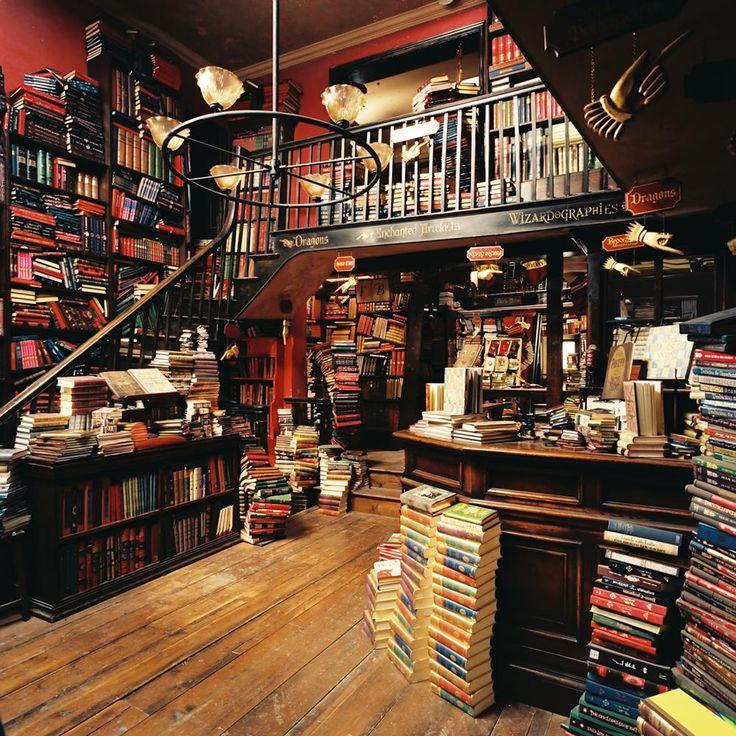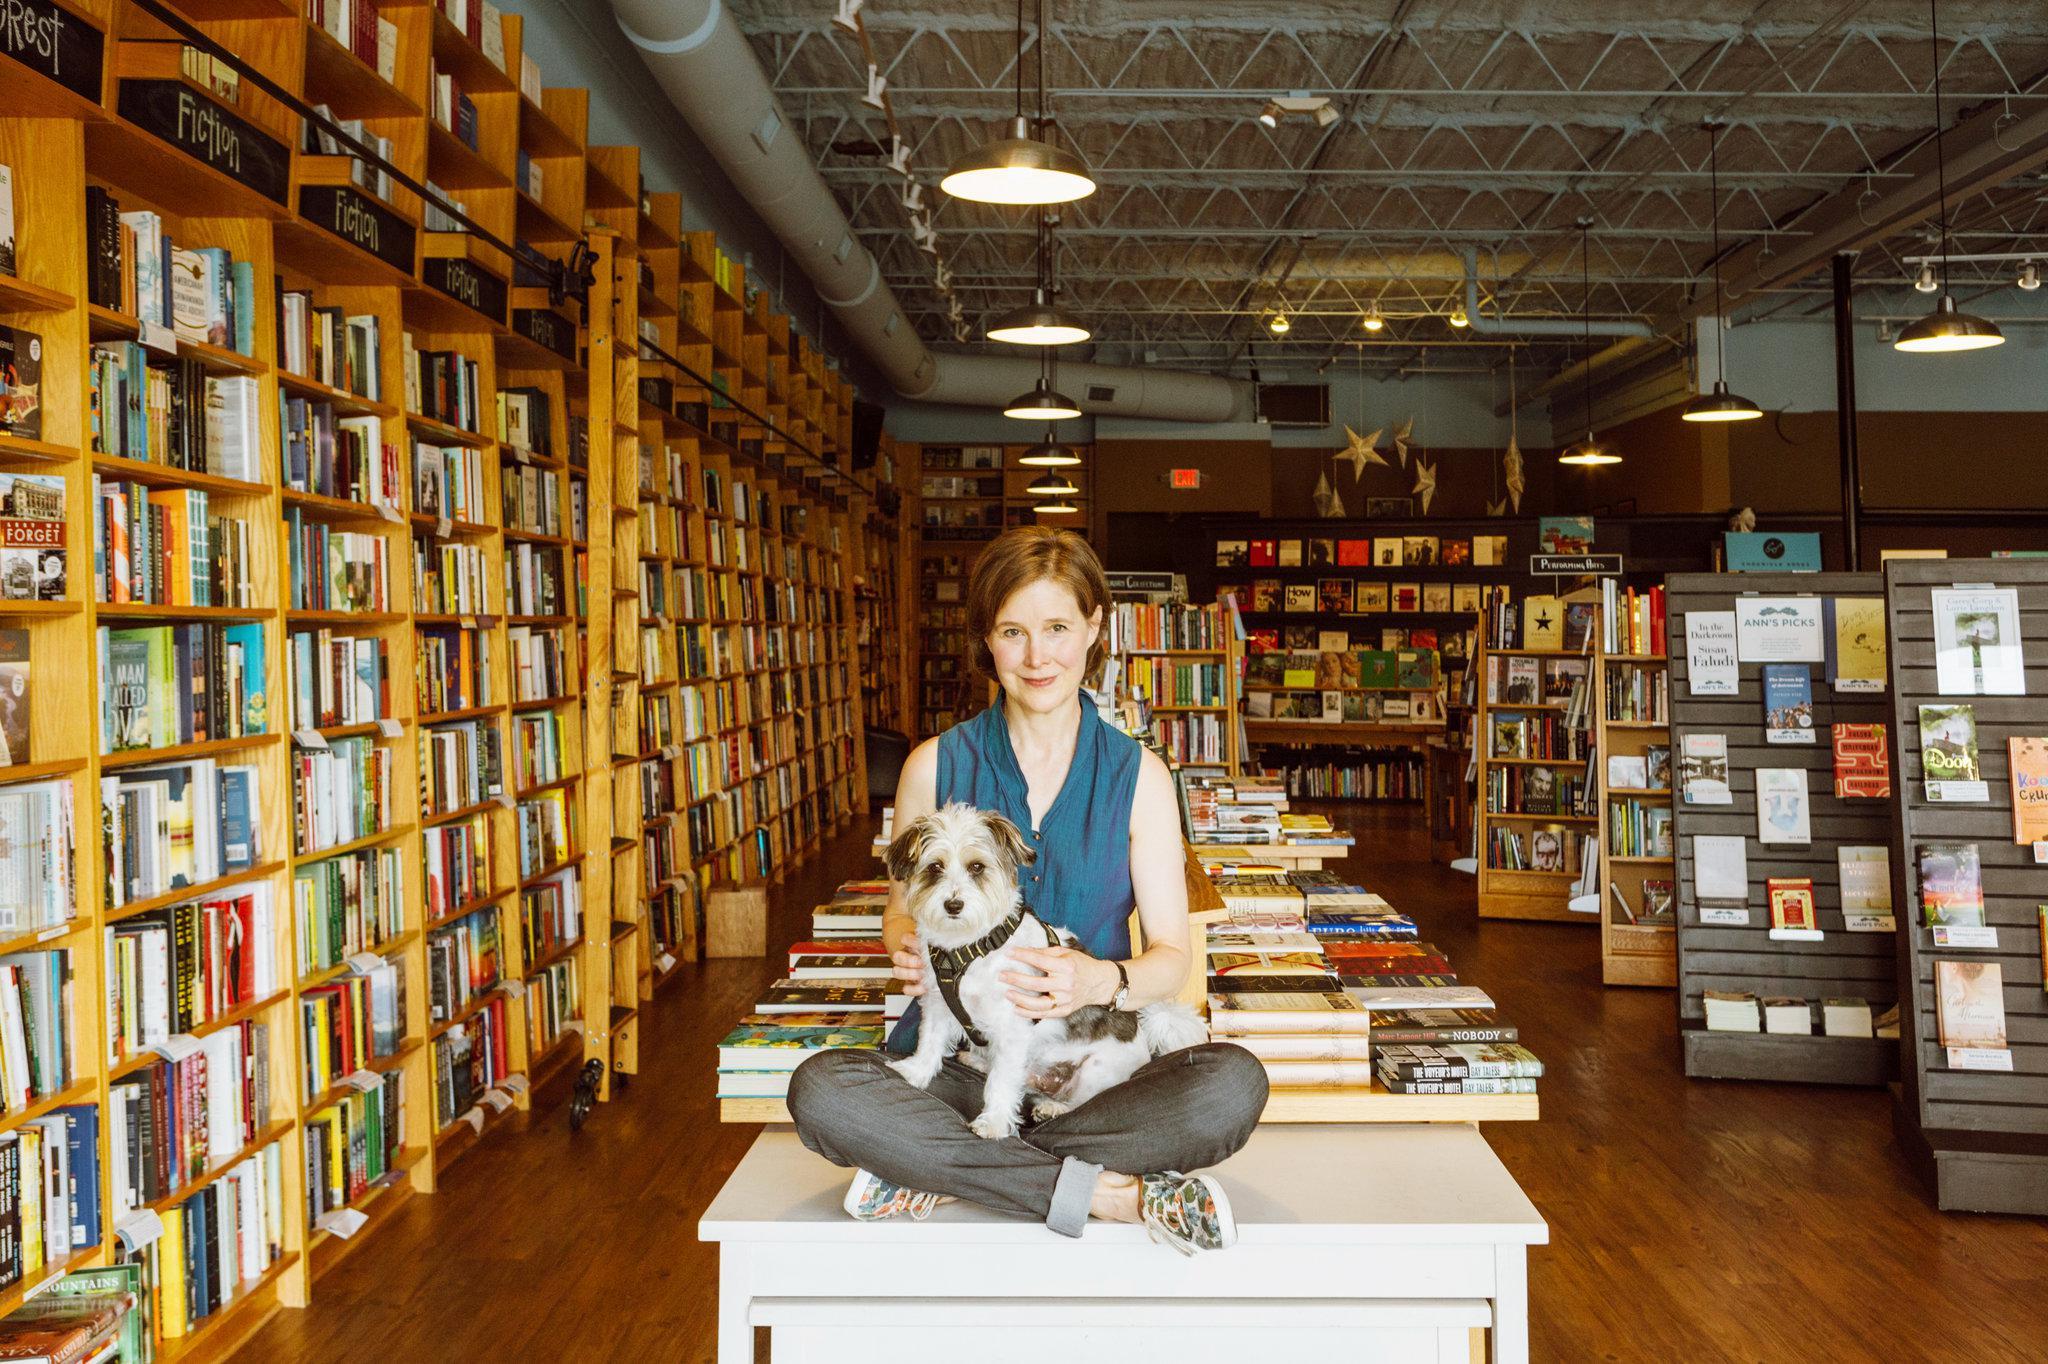The first image is the image on the left, the second image is the image on the right. Assess this claim about the two images: "The left image shows a bookstore with a second floor of bookshelves surrounded by balcony rails.". Correct or not? Answer yes or no. Yes. The first image is the image on the left, the second image is the image on the right. Considering the images on both sides, is "There is a stairway visible in one of the images." valid? Answer yes or no. Yes. 